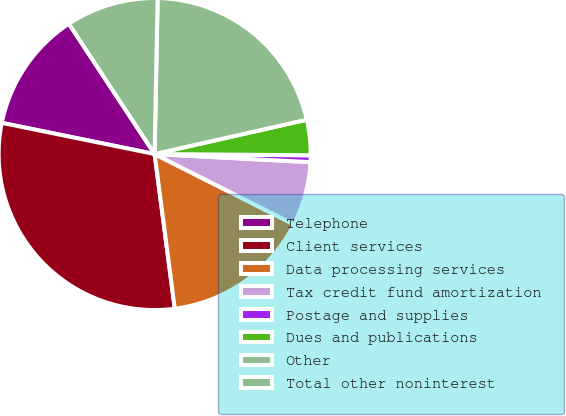Convert chart to OTSL. <chart><loc_0><loc_0><loc_500><loc_500><pie_chart><fcel>Telephone<fcel>Client services<fcel>Data processing services<fcel>Tax credit fund amortization<fcel>Postage and supplies<fcel>Dues and publications<fcel>Other<fcel>Total other noninterest<nl><fcel>12.53%<fcel>30.27%<fcel>15.49%<fcel>6.62%<fcel>0.7%<fcel>3.66%<fcel>21.16%<fcel>9.57%<nl></chart> 